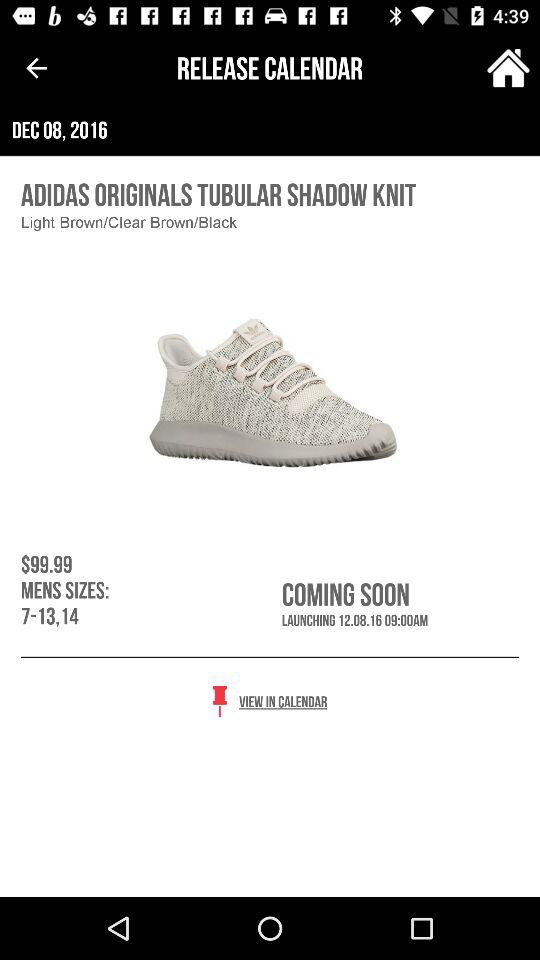What is the selected date? The date is December 8, 2016. 